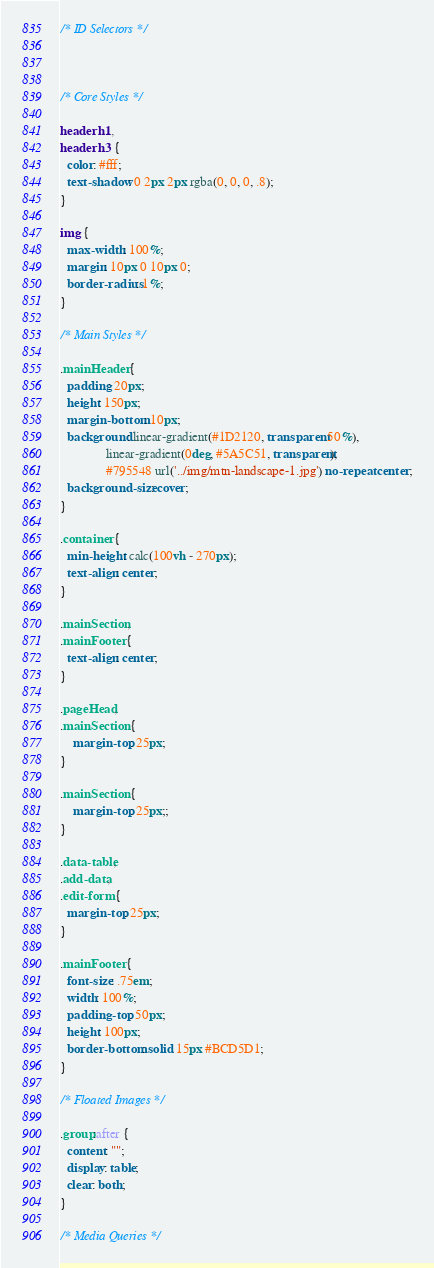<code> <loc_0><loc_0><loc_500><loc_500><_CSS_>/* ID Selectors */



/* Core Styles */

header h1,
header h3 {
  color: #fff;
  text-shadow: 0 2px 2px rgba(0, 0, 0, .8);
}

img {
  max-width: 100%;
  margin: 10px 0 10px 0;
  border-radius: 1%;
}

/* Main Styles */

.mainHeader {
  padding: 20px;
  height: 150px;
  margin-bottom: 10px;
  background: linear-gradient(#1D2120, transparent 50%),
              linear-gradient(0deg, #5A5C51, transparent),
              #795548 url('../img/mtn-landscape-1.jpg') no-repeat center;
  background-size: cover;
}

.container {
  min-height: calc(100vh - 270px);
  text-align: center;
}

.mainSection,
.mainFooter {
  text-align: center;
}

.pageHead,
.mainSection {
    margin-top: 25px;
}

.mainSection {
    margin-top: 25px;;
}

.data-table,
.add-data,
.edit-form {
  margin-top: 25px;
}

.mainFooter {
  font-size: .75em;
  width: 100%;
  padding-top: 50px;
  height: 100px;
  border-bottom: solid 15px #BCD5D1;
}

/* Floated Images */

.group:after {
  content: "";
  display: table;
  clear: both;
}

/* Media Queries */
</code> 